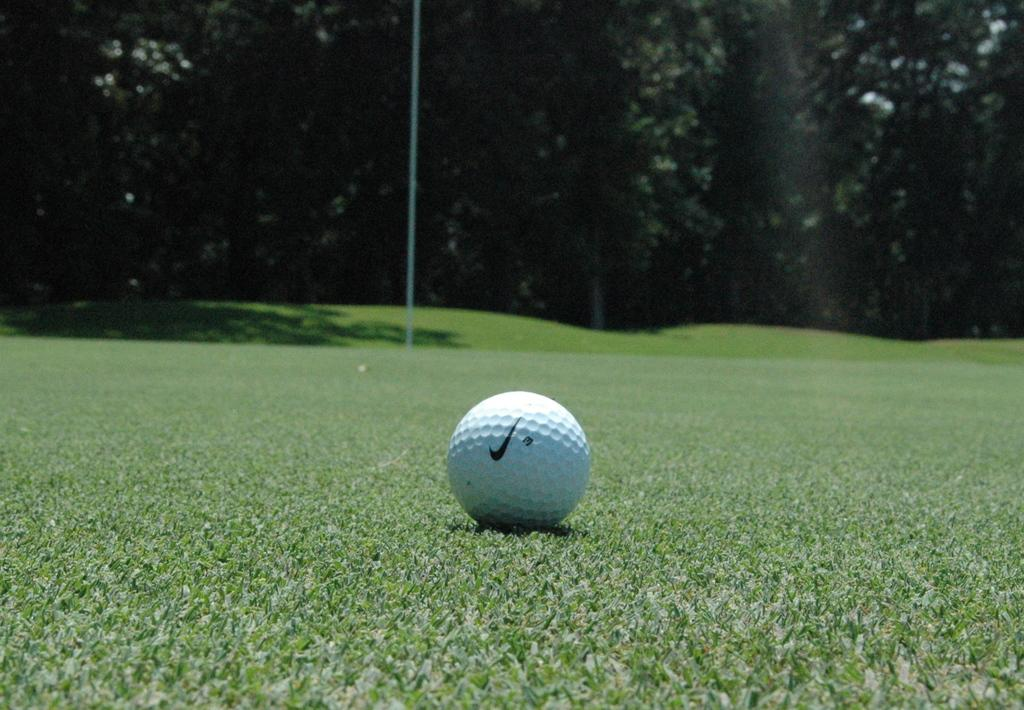What object is on the ground in the image? There is a white golf ball on the ground. What else can be seen on the ground in the image? There is a pole on the ground. What type of vegetation is visible in the background of the image? There are trees in the background of the image. What color is the grass in the image? The grass is green in the image. Where is the station located in the image? There is no station present in the image. What type of vest is the goose wearing in the image? There is no goose or vest present in the image. 